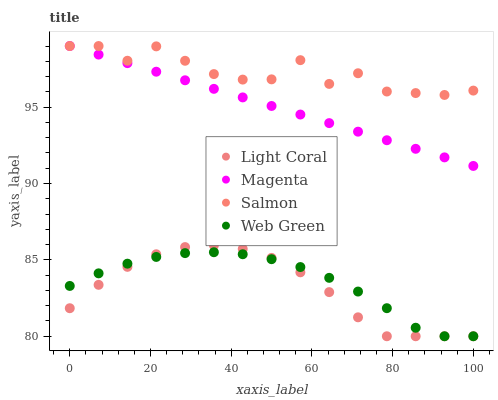Does Light Coral have the minimum area under the curve?
Answer yes or no. Yes. Does Salmon have the maximum area under the curve?
Answer yes or no. Yes. Does Magenta have the minimum area under the curve?
Answer yes or no. No. Does Magenta have the maximum area under the curve?
Answer yes or no. No. Is Magenta the smoothest?
Answer yes or no. Yes. Is Salmon the roughest?
Answer yes or no. Yes. Is Salmon the smoothest?
Answer yes or no. No. Is Magenta the roughest?
Answer yes or no. No. Does Light Coral have the lowest value?
Answer yes or no. Yes. Does Magenta have the lowest value?
Answer yes or no. No. Does Salmon have the highest value?
Answer yes or no. Yes. Does Web Green have the highest value?
Answer yes or no. No. Is Light Coral less than Magenta?
Answer yes or no. Yes. Is Salmon greater than Web Green?
Answer yes or no. Yes. Does Web Green intersect Light Coral?
Answer yes or no. Yes. Is Web Green less than Light Coral?
Answer yes or no. No. Is Web Green greater than Light Coral?
Answer yes or no. No. Does Light Coral intersect Magenta?
Answer yes or no. No. 